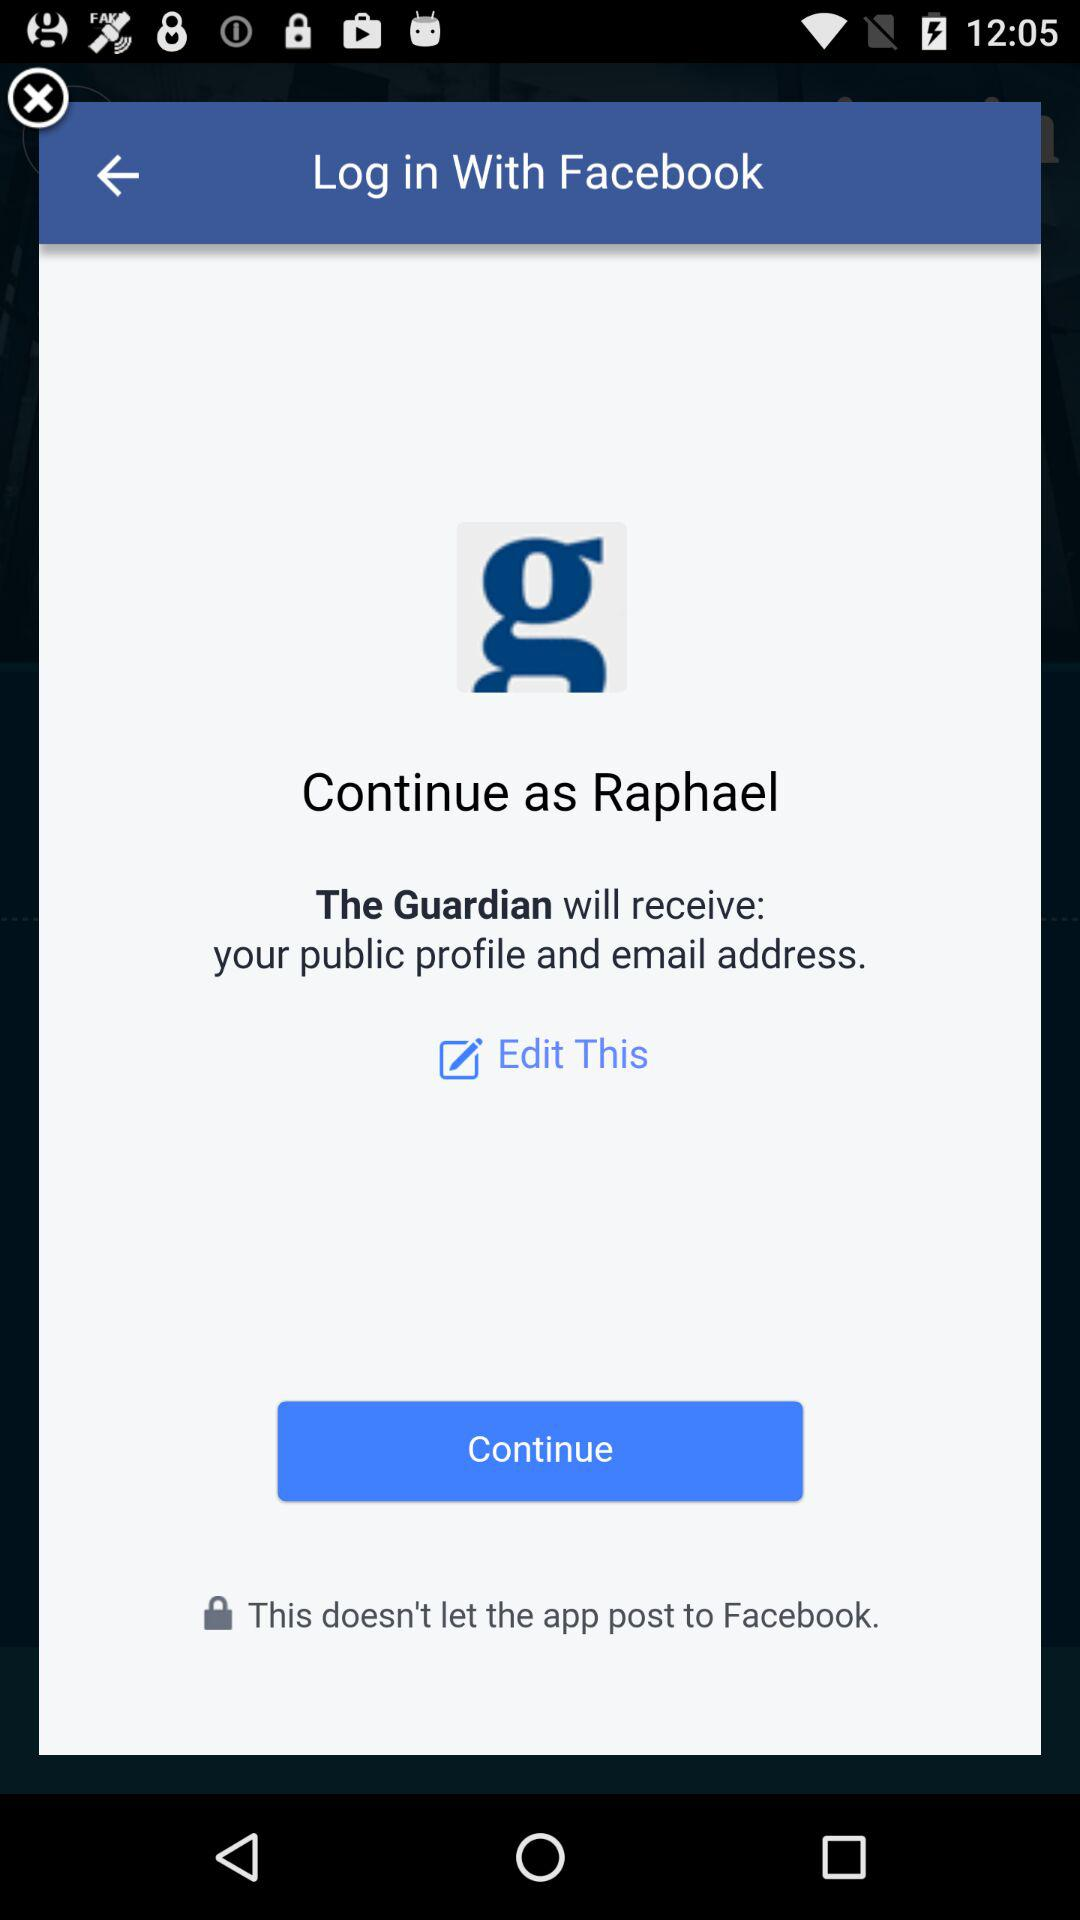What application is asking for permission? The application asking for permission is "The Guardian". 